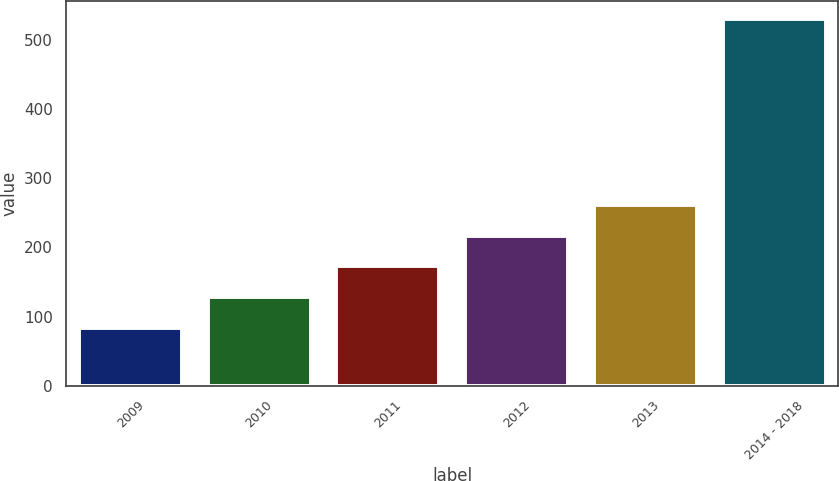Convert chart. <chart><loc_0><loc_0><loc_500><loc_500><bar_chart><fcel>2009<fcel>2010<fcel>2011<fcel>2012<fcel>2013<fcel>2014 - 2018<nl><fcel>83<fcel>127.7<fcel>172.4<fcel>217.1<fcel>261.8<fcel>530<nl></chart> 